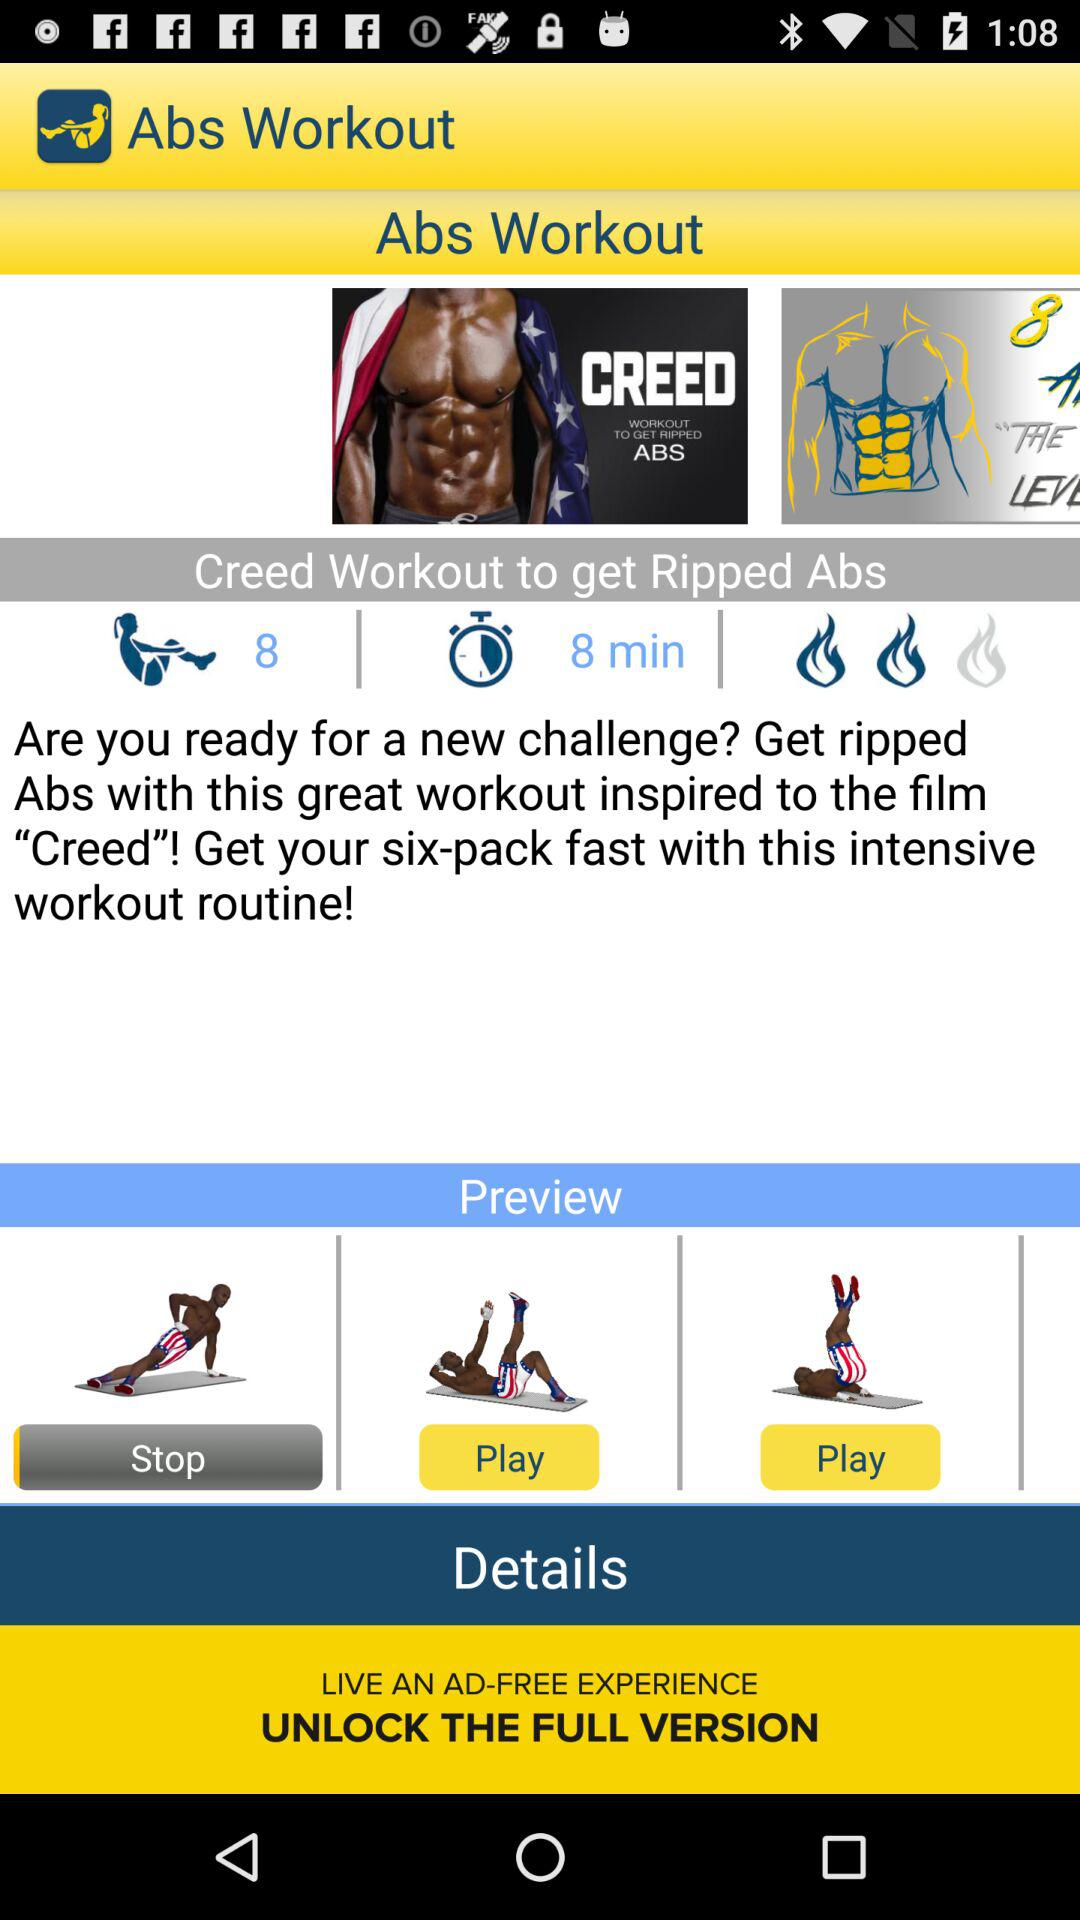What is the duration of the Creed workout? The duration of the Creed workout is 8 minutes. 